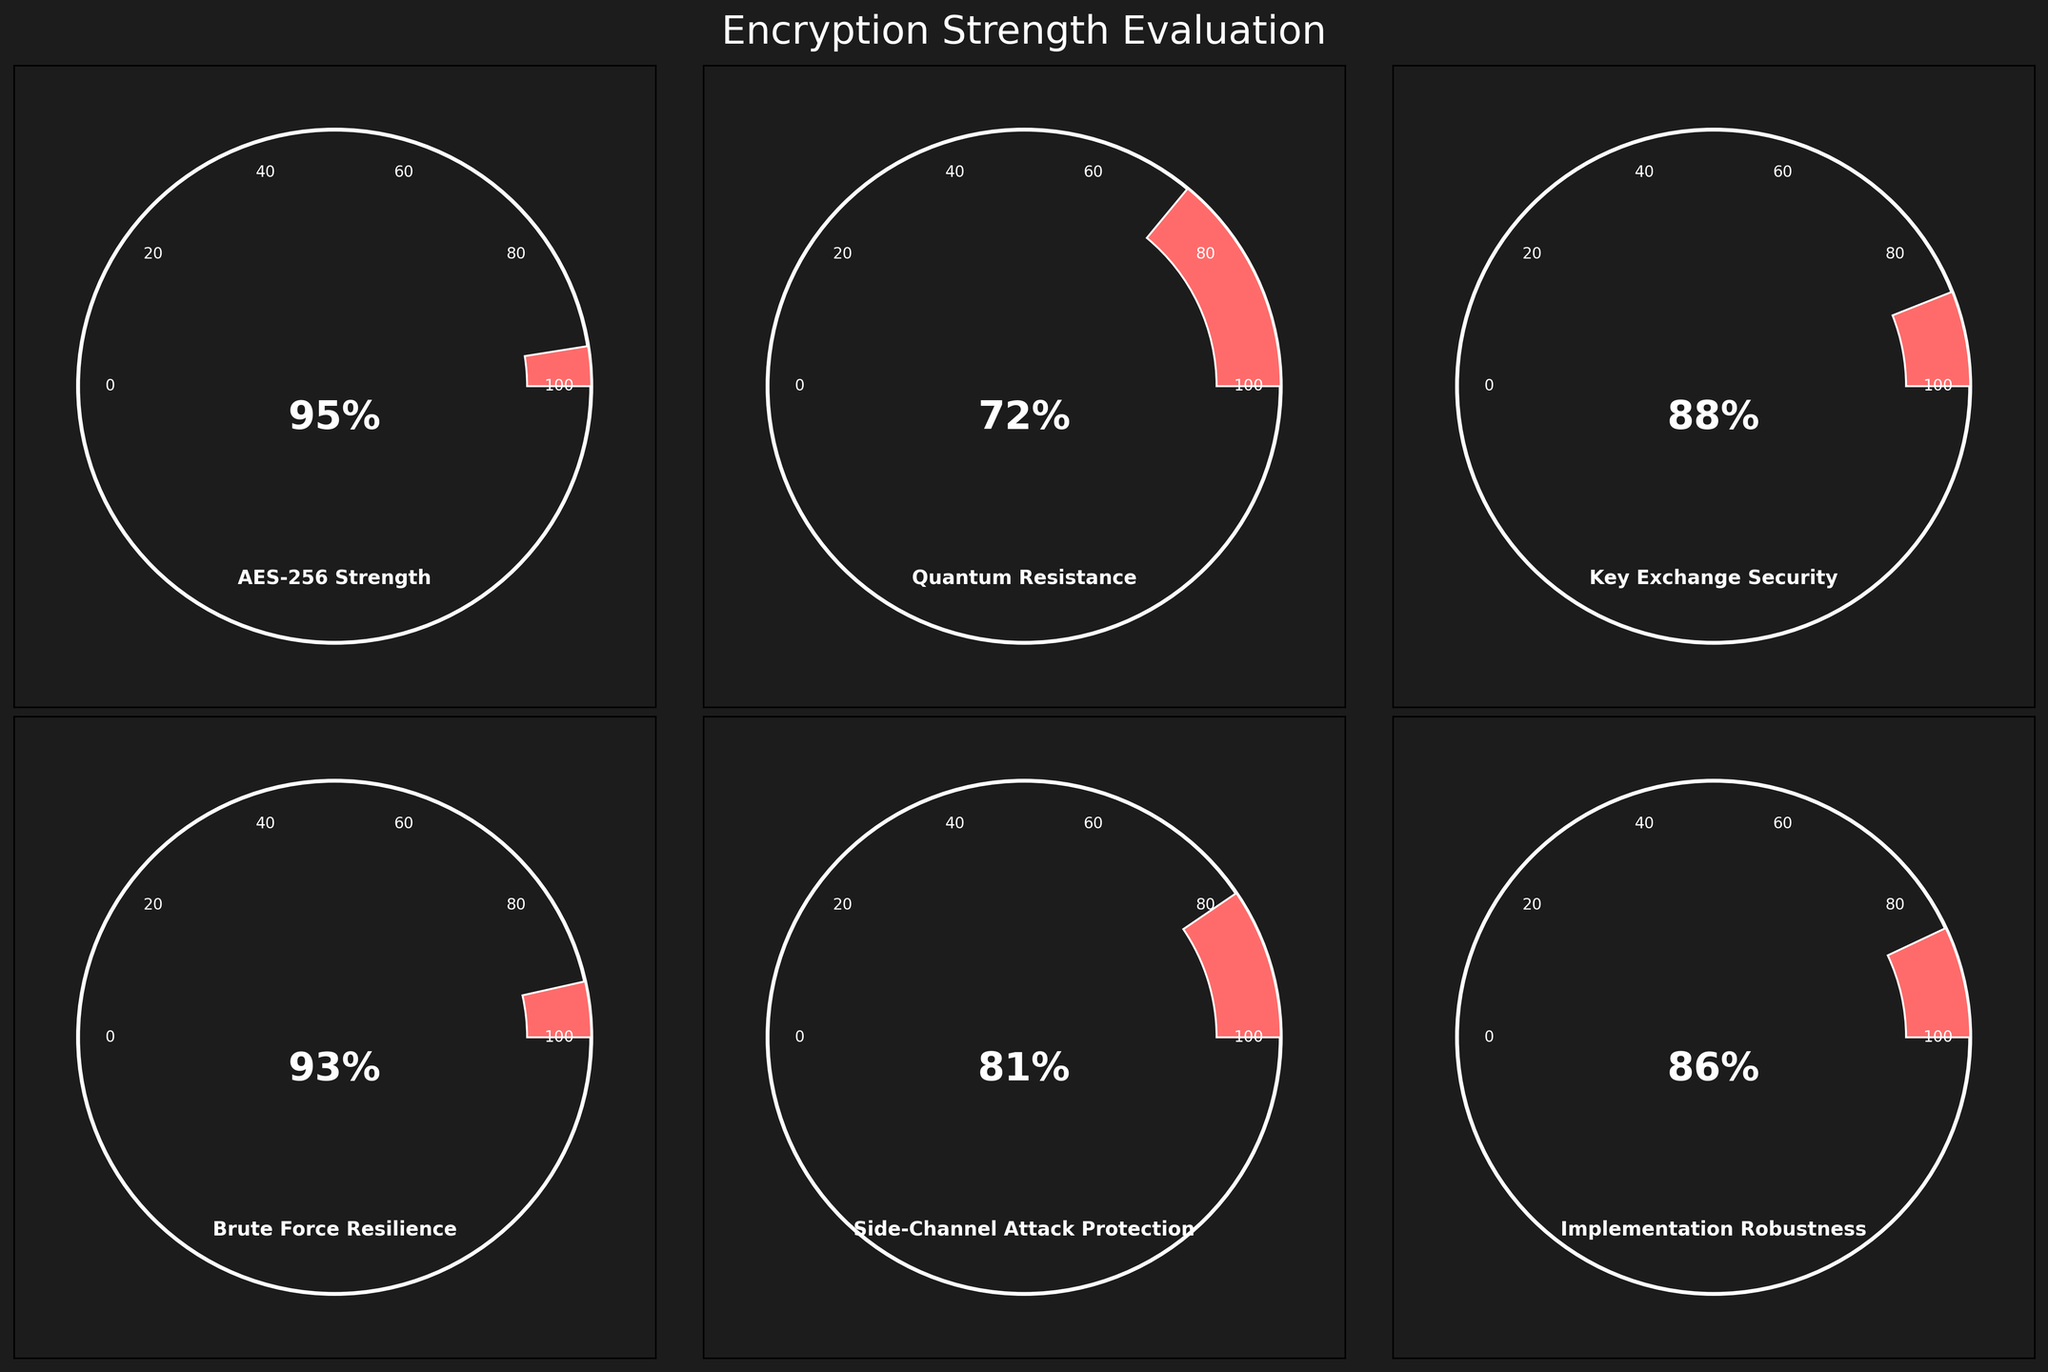What's the title of the figure? The title is usually found at the top of the figure. In this case, it should be easy to spot due to its placement and color. It reads "Encryption Strength Evaluation".
Answer: Encryption Strength Evaluation What value is shown for AES-256 Strength? Locate the gauge labeled "AES-256 Strength". Observe the percentage inside the gauge.
Answer: 95% Which category has the highest value? Compare the values indicated inside each gauge. The gauge corresponding to the highest number is the one we seek. AES-256 Strength has the highest value at 95%.
Answer: AES-256 Strength Which category shows greater value, Brute Force Resilience or Quantum Resistance? Look at the values inside the respective gauges for Brute Force Resilience (93%) and Quantum Resistance (72%). Compare them.
Answer: Brute Force Resilience What's the average encryption strength across all categories? Sum up all the values of the gauges and divide by the number of categories. (95 + 72 + 88 + 93 + 81 + 86) / 6 = 85.83
Answer: 85.83 What is the combined value of Key Exchange Security and Side-Channel Attack Protection? Sum the values for Key Exchange Security (88%) and Side-Channel Attack Protection (81%). 88 + 81 = 169.
Answer: 169 Which category is closest to the average value of 85.83? Compare each category's value against the average of 85.83. The values are AES-256 Strength (95), Quantum Resistance (72), Key Exchange Security (88), Brute Force Resilience (93), Side-Channel Attack Protection (81), and Implementation Robustness (86). Implementation Robustness at 86 is the closest.
Answer: Implementation Robustness How many gauges show a value above 80%? Count the number of gauges with values greater than 80. Those are AES-256 Strength (95), Key Exchange Security (88), Brute Force Resilience (93), Side-Channel Attack Protection (81), and Implementation Robustness (86). There are 5 such gauges.
Answer: 5 Does any category have a value below 70%? Look at the values in all gauges and see if any of them are below 70%. All values are above 70%.
Answer: No What is the difference in value between Implementation Robustness and Quantum Resistance? Subtract the value of Quantum Resistance (72%) from Implementation Robustness (86%). 86 - 72 = 14.
Answer: 14 